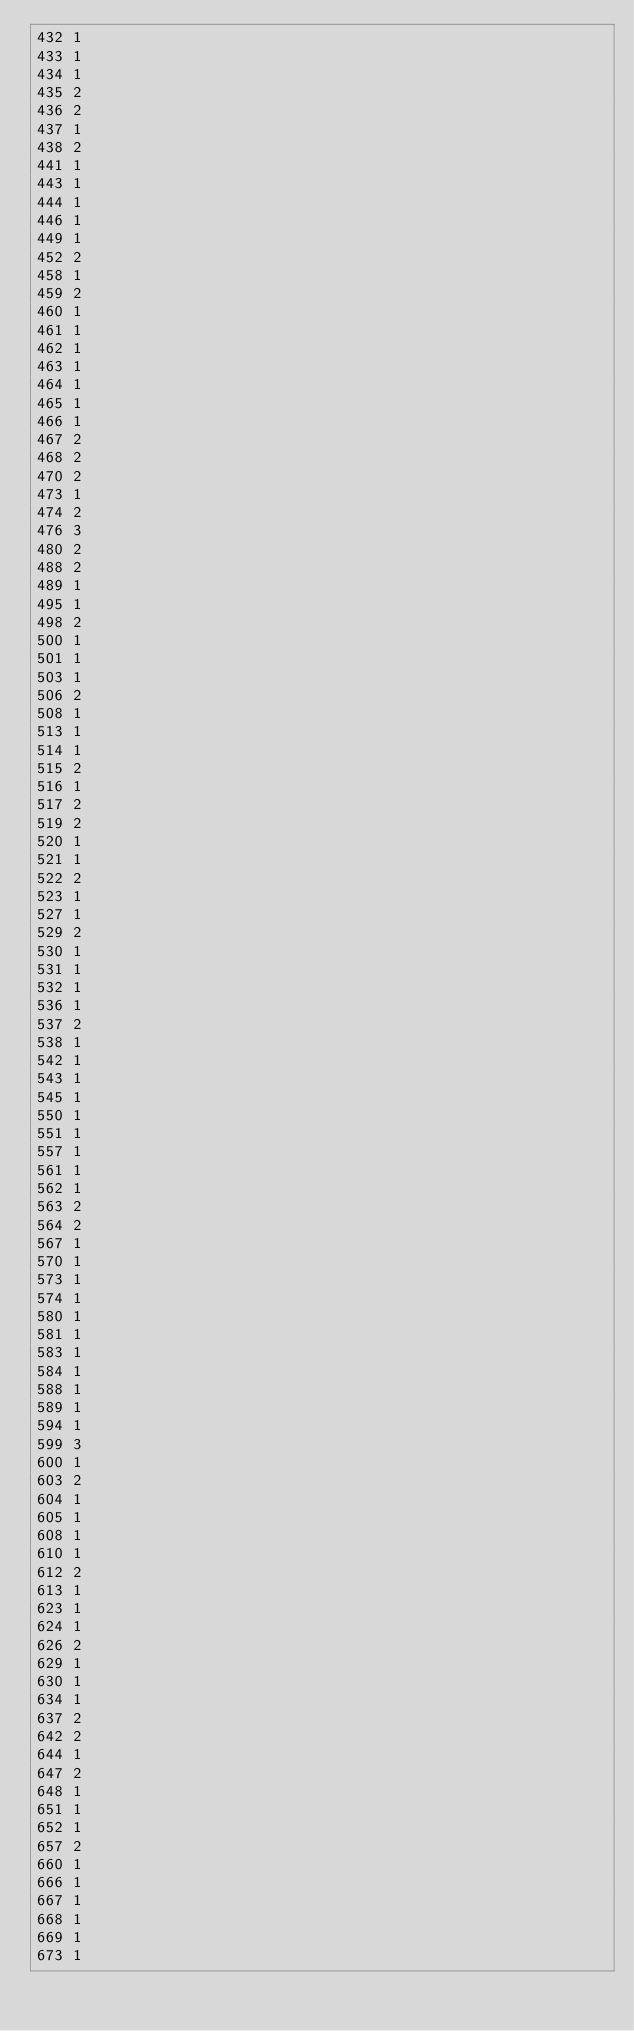Convert code to text. <code><loc_0><loc_0><loc_500><loc_500><_SQL_>432	1
433	1
434	1
435	2
436	2
437	1
438	2
441	1
443	1
444	1
446	1
449	1
452	2
458	1
459	2
460	1
461	1
462	1
463	1
464	1
465	1
466	1
467	2
468	2
470	2
473	1
474	2
476	3
480	2
488	2
489	1
495	1
498	2
500	1
501	1
503	1
506	2
508	1
513	1
514	1
515	2
516	1
517	2
519	2
520	1
521	1
522	2
523	1
527	1
529	2
530	1
531	1
532	1
536	1
537	2
538	1
542	1
543	1
545	1
550	1
551	1
557	1
561	1
562	1
563	2
564	2
567	1
570	1
573	1
574	1
580	1
581	1
583	1
584	1
588	1
589	1
594	1
599	3
600	1
603	2
604	1
605	1
608	1
610	1
612	2
613	1
623	1
624	1
626	2
629	1
630	1
634	1
637	2
642	2
644	1
647	2
648	1
651	1
652	1
657	2
660	1
666	1
667	1
668	1
669	1
673	1</code> 